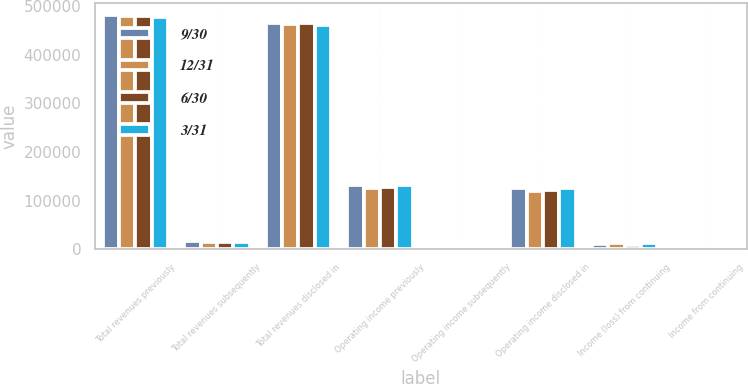Convert chart to OTSL. <chart><loc_0><loc_0><loc_500><loc_500><stacked_bar_chart><ecel><fcel>Total revenues previously<fcel>Total revenues subsequently<fcel>Total revenues disclosed in<fcel>Operating income previously<fcel>Operating income subsequently<fcel>Operating income disclosed in<fcel>Income (loss) from continuing<fcel>Income from continuing<nl><fcel>9/30<fcel>482475<fcel>16298<fcel>466177<fcel>132245<fcel>5962<fcel>126283<fcel>11948<fcel>4090<nl><fcel>12/31<fcel>480333<fcel>16108<fcel>464225<fcel>126944<fcel>6283<fcel>120661<fcel>12339<fcel>4526<nl><fcel>6/30<fcel>480241<fcel>15414<fcel>464827<fcel>128655<fcel>5952<fcel>122703<fcel>9029<fcel>4773<nl><fcel>3/31<fcel>477365<fcel>16091<fcel>461274<fcel>133239<fcel>6285<fcel>126954<fcel>13146<fcel>3850<nl></chart> 